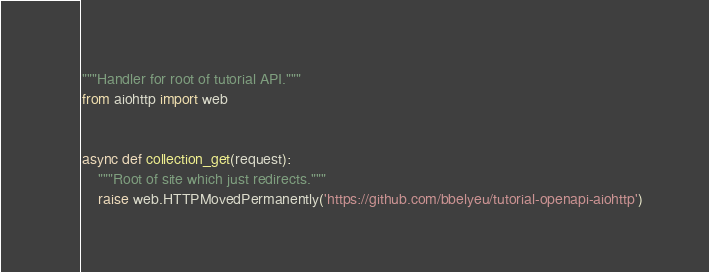<code> <loc_0><loc_0><loc_500><loc_500><_Python_>"""Handler for root of tutorial API."""
from aiohttp import web


async def collection_get(request):
    """Root of site which just redirects."""
    raise web.HTTPMovedPermanently('https://github.com/bbelyeu/tutorial-openapi-aiohttp')
</code> 